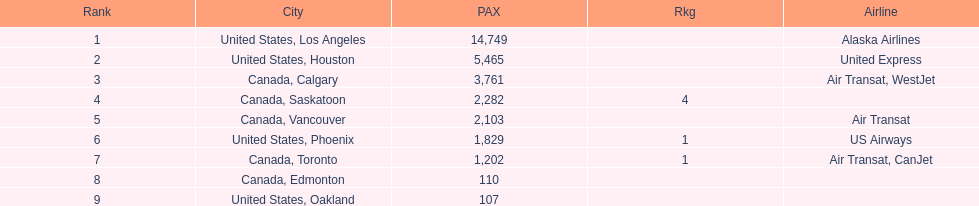Which canadian city had the most passengers traveling from manzanillo international airport in 2013? Calgary. 